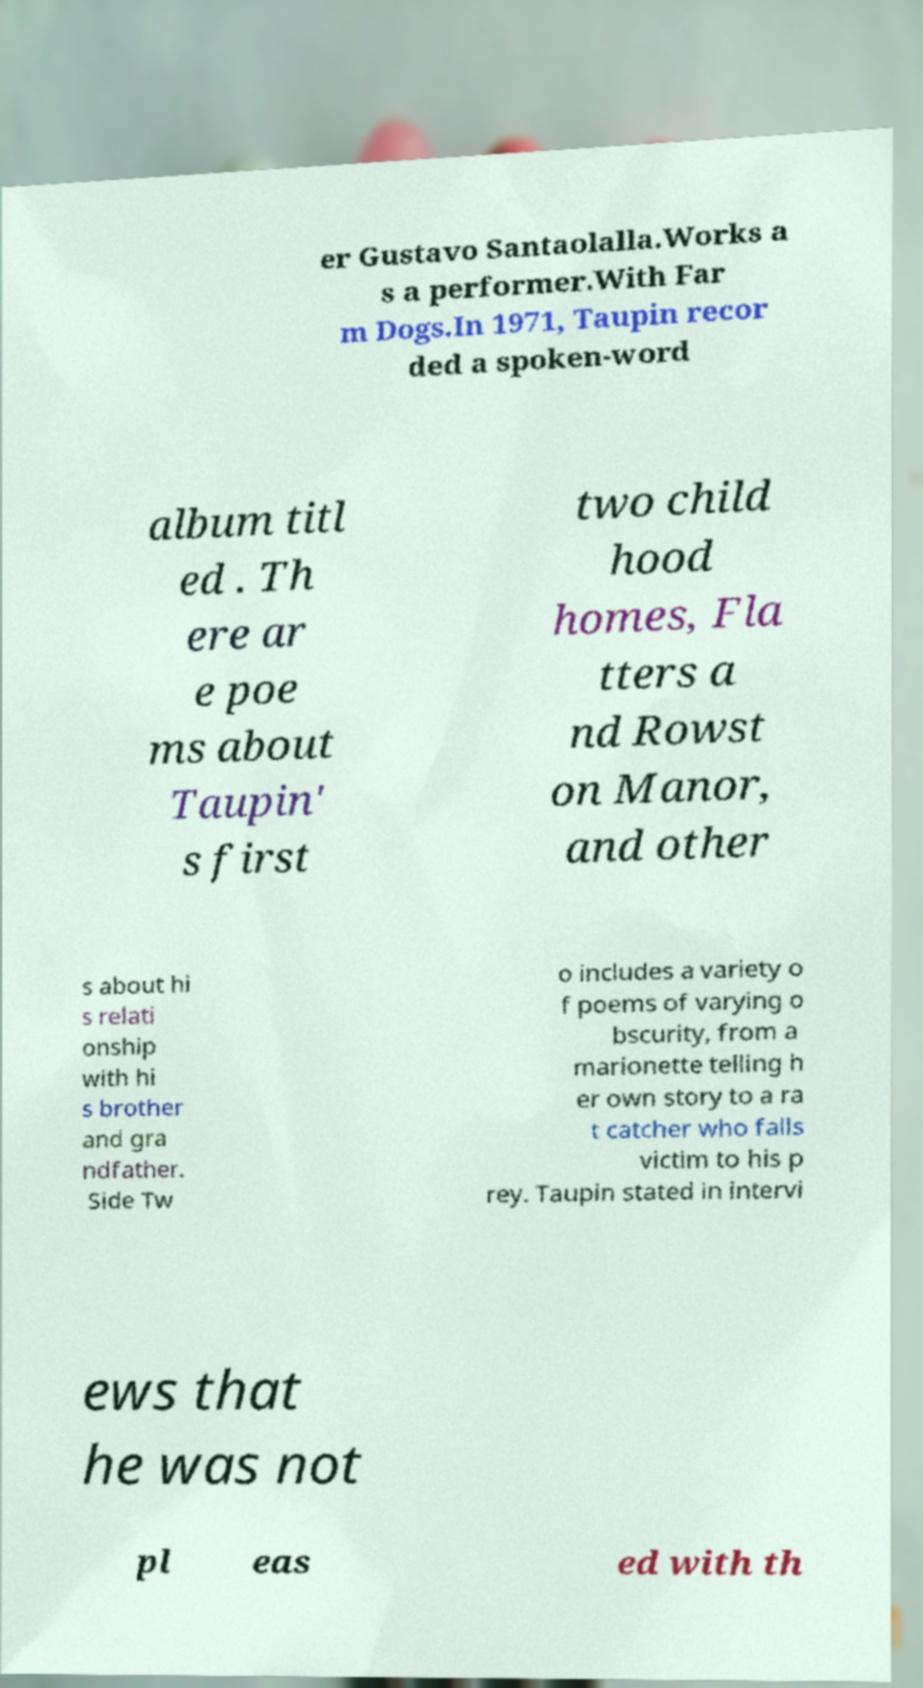Could you assist in decoding the text presented in this image and type it out clearly? er Gustavo Santaolalla.Works a s a performer.With Far m Dogs.In 1971, Taupin recor ded a spoken-word album titl ed . Th ere ar e poe ms about Taupin' s first two child hood homes, Fla tters a nd Rowst on Manor, and other s about hi s relati onship with hi s brother and gra ndfather. Side Tw o includes a variety o f poems of varying o bscurity, from a marionette telling h er own story to a ra t catcher who falls victim to his p rey. Taupin stated in intervi ews that he was not pl eas ed with th 